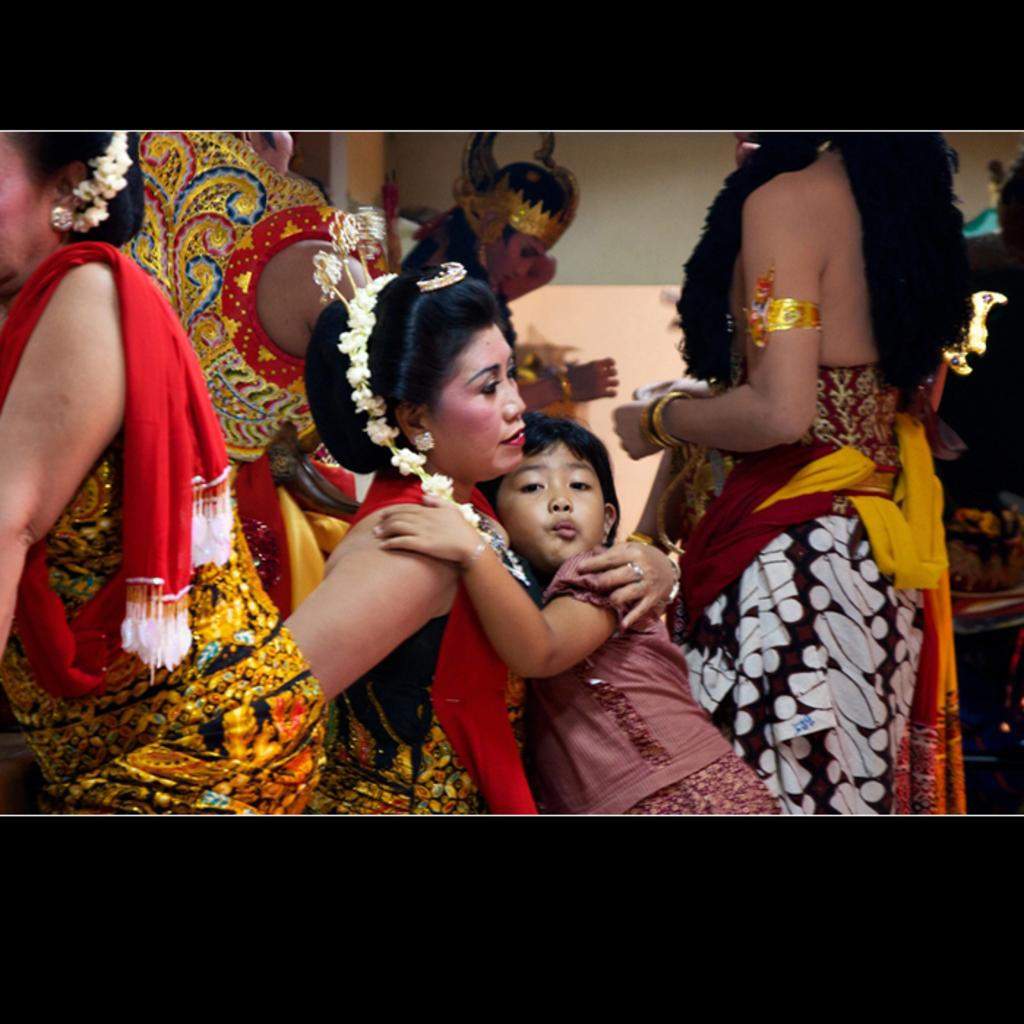How many people are in the image? There is a group of persons in the image. What are the persons wearing? The persons are wearing different costumes. What positions are the persons in? Some of the persons are standing, and some are sitting. How many light bulbs are visible in the image? There is no mention of light bulbs in the provided facts, so we cannot determine their presence or quantity in the image. 